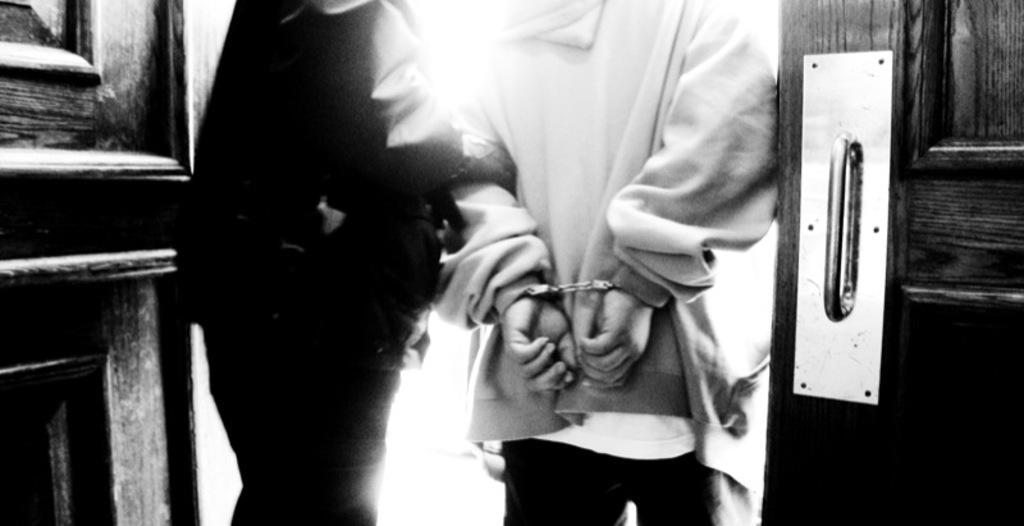In one or two sentences, can you explain what this image depicts? This is a black and white image and here we can see people and one of them is wearing handcuffs. In the background, there are doors. 